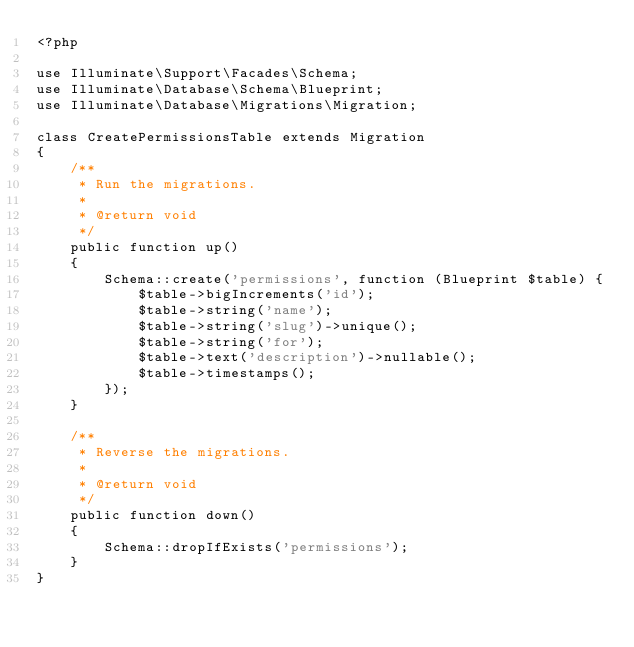<code> <loc_0><loc_0><loc_500><loc_500><_PHP_><?php

use Illuminate\Support\Facades\Schema;
use Illuminate\Database\Schema\Blueprint;
use Illuminate\Database\Migrations\Migration;

class CreatePermissionsTable extends Migration
{
    /**
     * Run the migrations.
     *
     * @return void
     */
    public function up()
    {
        Schema::create('permissions', function (Blueprint $table) {
            $table->bigIncrements('id');
            $table->string('name');
            $table->string('slug')->unique();
            $table->string('for');
            $table->text('description')->nullable();
            $table->timestamps();
        });
    }

    /**
     * Reverse the migrations.
     *
     * @return void
     */
    public function down()
    {
        Schema::dropIfExists('permissions');
    }
}
</code> 